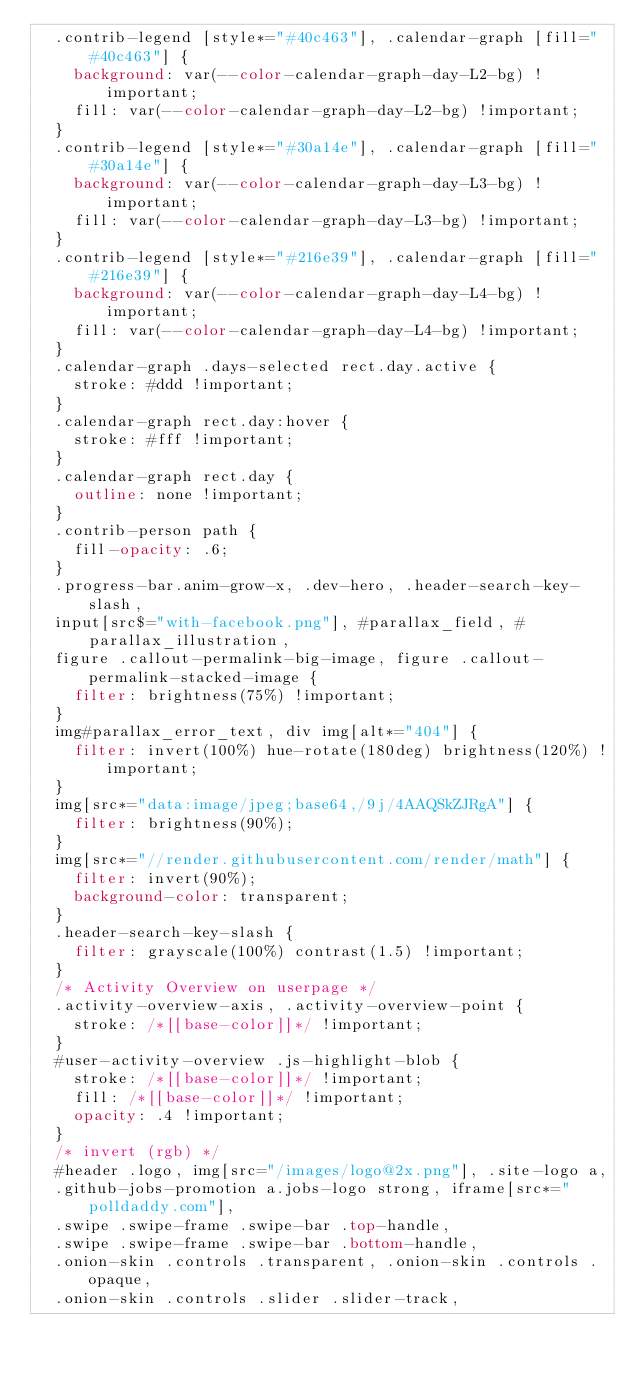Convert code to text. <code><loc_0><loc_0><loc_500><loc_500><_CSS_>  .contrib-legend [style*="#40c463"], .calendar-graph [fill="#40c463"] {
    background: var(--color-calendar-graph-day-L2-bg) !important;
    fill: var(--color-calendar-graph-day-L2-bg) !important;
  }
  .contrib-legend [style*="#30a14e"], .calendar-graph [fill="#30a14e"] {
    background: var(--color-calendar-graph-day-L3-bg) !important;
    fill: var(--color-calendar-graph-day-L3-bg) !important;
  }
  .contrib-legend [style*="#216e39"], .calendar-graph [fill="#216e39"] {
    background: var(--color-calendar-graph-day-L4-bg) !important;
    fill: var(--color-calendar-graph-day-L4-bg) !important;
  }
  .calendar-graph .days-selected rect.day.active {
    stroke: #ddd !important;
  }
  .calendar-graph rect.day:hover {
    stroke: #fff !important;
  }
  .calendar-graph rect.day {
    outline: none !important;
  }
  .contrib-person path {
    fill-opacity: .6;
  }
  .progress-bar.anim-grow-x, .dev-hero, .header-search-key-slash,
  input[src$="with-facebook.png"], #parallax_field, #parallax_illustration,
  figure .callout-permalink-big-image, figure .callout-permalink-stacked-image {
    filter: brightness(75%) !important;
  }
  img#parallax_error_text, div img[alt*="404"] {
    filter: invert(100%) hue-rotate(180deg) brightness(120%) !important;
  }
  img[src*="data:image/jpeg;base64,/9j/4AAQSkZJRgA"] {
    filter: brightness(90%);
  }
  img[src*="//render.githubusercontent.com/render/math"] {
    filter: invert(90%);
    background-color: transparent;
  }
  .header-search-key-slash {
    filter: grayscale(100%) contrast(1.5) !important;
  }
  /* Activity Overview on userpage */
  .activity-overview-axis, .activity-overview-point {
    stroke: /*[[base-color]]*/ !important;
  }
  #user-activity-overview .js-highlight-blob {
    stroke: /*[[base-color]]*/ !important;
    fill: /*[[base-color]]*/ !important;
    opacity: .4 !important;
  }
  /* invert (rgb) */
  #header .logo, img[src="/images/logo@2x.png"], .site-logo a,
  .github-jobs-promotion a.jobs-logo strong, iframe[src*="polldaddy.com"],
  .swipe .swipe-frame .swipe-bar .top-handle,
  .swipe .swipe-frame .swipe-bar .bottom-handle,
  .onion-skin .controls .transparent, .onion-skin .controls .opaque,
  .onion-skin .controls .slider .slider-track,</code> 